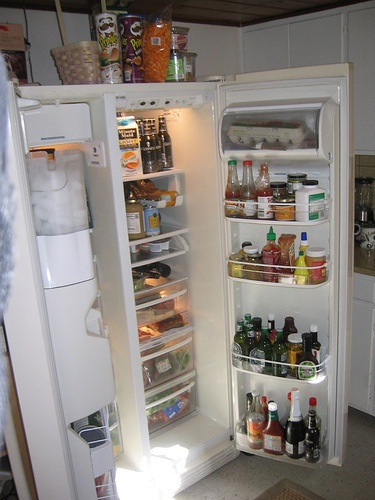Describe the objects in this image and their specific colors. I can see refrigerator in darkgray, black, lightgray, and gray tones, bottle in black, darkgray, gray, and maroon tones, bottle in black, darkgray, gray, and tan tones, bottle in black, maroon, darkgray, and gray tones, and bottle in black, gray, maroon, and darkgray tones in this image. 